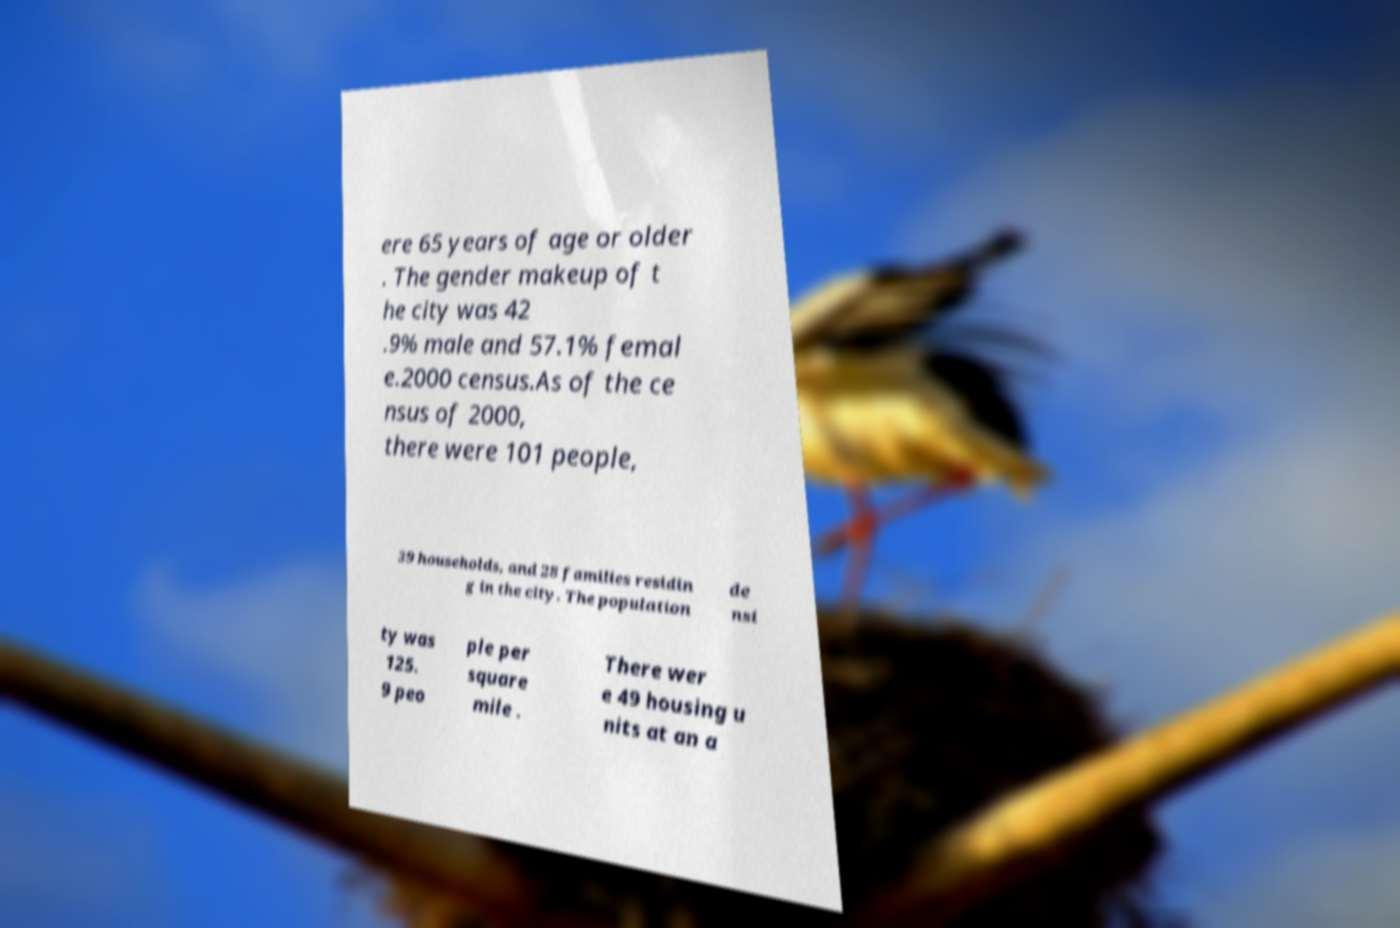What messages or text are displayed in this image? I need them in a readable, typed format. ere 65 years of age or older . The gender makeup of t he city was 42 .9% male and 57.1% femal e.2000 census.As of the ce nsus of 2000, there were 101 people, 39 households, and 28 families residin g in the city. The population de nsi ty was 125. 9 peo ple per square mile . There wer e 49 housing u nits at an a 